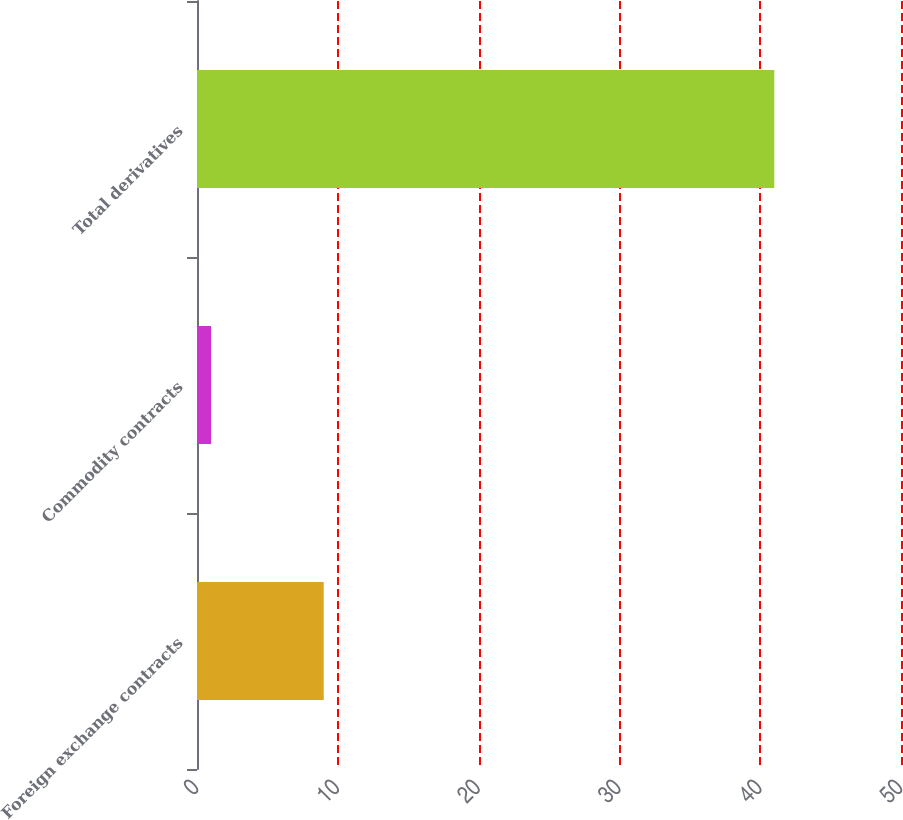Convert chart to OTSL. <chart><loc_0><loc_0><loc_500><loc_500><bar_chart><fcel>Foreign exchange contracts<fcel>Commodity contracts<fcel>Total derivatives<nl><fcel>9<fcel>1<fcel>41<nl></chart> 